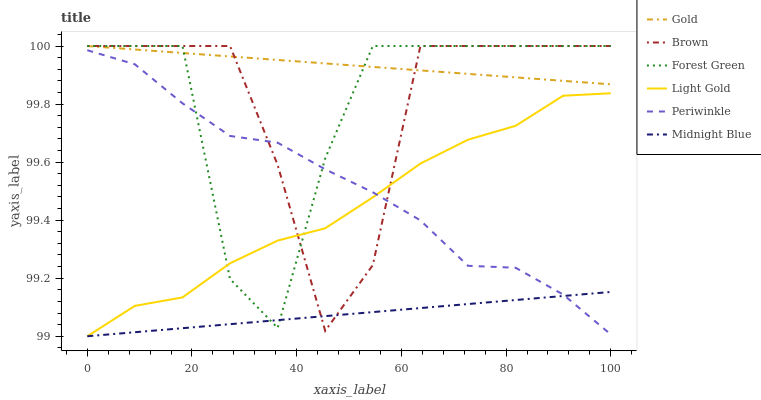Does Gold have the minimum area under the curve?
Answer yes or no. No. Does Midnight Blue have the maximum area under the curve?
Answer yes or no. No. Is Midnight Blue the smoothest?
Answer yes or no. No. Is Midnight Blue the roughest?
Answer yes or no. No. Does Gold have the lowest value?
Answer yes or no. No. Does Midnight Blue have the highest value?
Answer yes or no. No. Is Periwinkle less than Gold?
Answer yes or no. Yes. Is Gold greater than Midnight Blue?
Answer yes or no. Yes. Does Periwinkle intersect Gold?
Answer yes or no. No. 